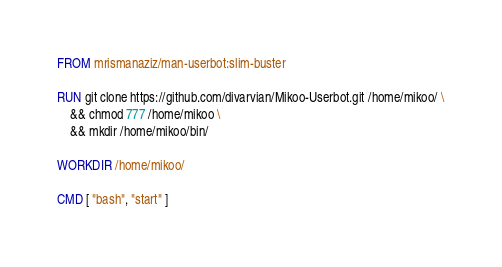Convert code to text. <code><loc_0><loc_0><loc_500><loc_500><_Dockerfile_>FROM mrismanaziz/man-userbot:slim-buster

RUN git clone https://github.com/divarvian/Mikoo-Userbot.git /home/mikoo/ \
    && chmod 777 /home/mikoo \
    && mkdir /home/mikoo/bin/

WORKDIR /home/mikoo/

CMD [ "bash", "start" ]
</code> 